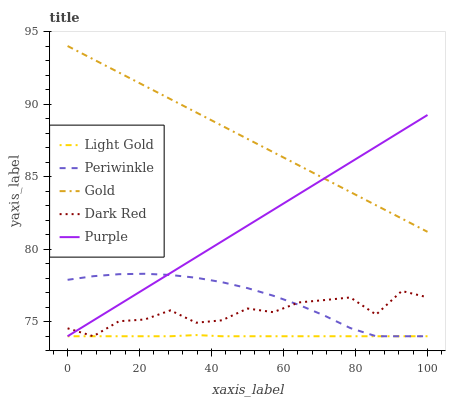Does Light Gold have the minimum area under the curve?
Answer yes or no. Yes. Does Gold have the maximum area under the curve?
Answer yes or no. Yes. Does Periwinkle have the minimum area under the curve?
Answer yes or no. No. Does Periwinkle have the maximum area under the curve?
Answer yes or no. No. Is Gold the smoothest?
Answer yes or no. Yes. Is Dark Red the roughest?
Answer yes or no. Yes. Is Periwinkle the smoothest?
Answer yes or no. No. Is Periwinkle the roughest?
Answer yes or no. No. Does Purple have the lowest value?
Answer yes or no. Yes. Does Gold have the lowest value?
Answer yes or no. No. Does Gold have the highest value?
Answer yes or no. Yes. Does Periwinkle have the highest value?
Answer yes or no. No. Is Light Gold less than Gold?
Answer yes or no. Yes. Is Gold greater than Dark Red?
Answer yes or no. Yes. Does Dark Red intersect Periwinkle?
Answer yes or no. Yes. Is Dark Red less than Periwinkle?
Answer yes or no. No. Is Dark Red greater than Periwinkle?
Answer yes or no. No. Does Light Gold intersect Gold?
Answer yes or no. No. 